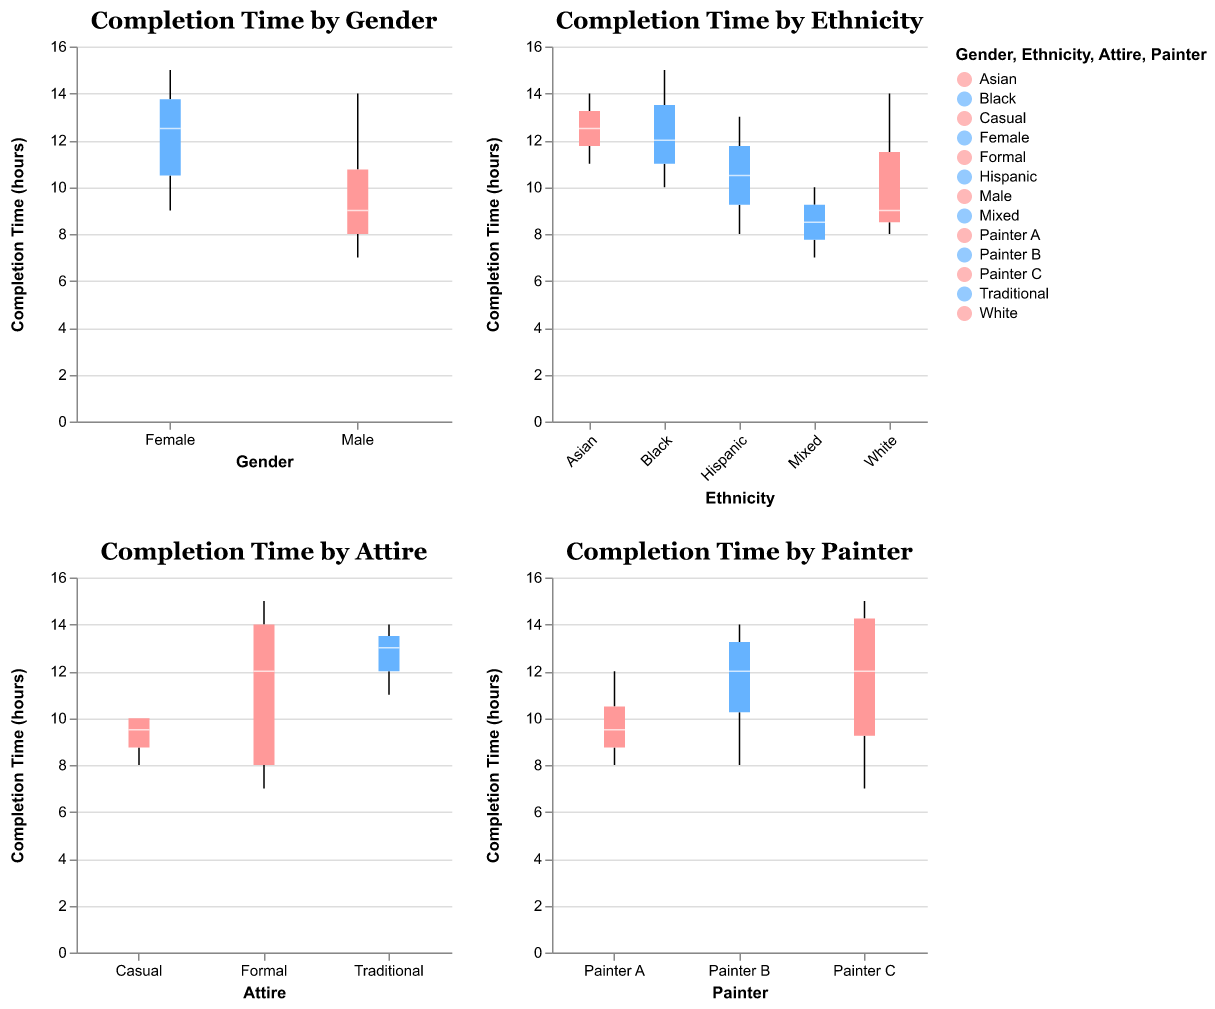How many gender categories are represented in the plot? There are box plots for two gender categories: Male and Female, as indicated by the x-axis labels in the "Completion Time by Gender" subplot.
Answer: 2 Which ethnicity has the widest range of completion times? In the "Completion Time by Ethnicity" subplot, compare the whisker lengths (representing the range of completion times) for each ethnicity. The box plot for Black has the widest range from the minimum to maximum completion times.
Answer: Black What is the average completion time for subjects wearing formal attire? In the "Completion Time by Attire" subplot, identify the data points for formal attire from the box plot. The completion times are 8, 12, 14, 15. Calculate the average: (8+12+14+15)/4 = 12.25 hours.
Answer: 12.25 hours Which painter has the smallest median completion time? In the "Completion Time by Painter" subplot, compare the median lines within the box plots for each painter. Painter C has the lowest median completion time.
Answer: Painter C Do male or female subjects generally have a higher median completion time? In the "Completion Time by Gender" subplot, compare the positions of the median lines in the box plots for Male and Female. The median line for Female is at a higher completion time than for Male.
Answer: Female Which attire category has the highest variability in completion times? In the "Completion Time by Attire" subplot, assess the spread of the data (whisker length and box size) for each attire. Casual attire shows higher variability than Formal and Traditional.
Answer: Casual What is the range of completion times for subjects painted by Painter A? In the "Completion Time by Painter" subplot, find the minimum and maximum whisker values for Painter A. The range is from 8 to 12 hours. Calculate the range as 12 - 8 = 4 hours.
Answer: 4 hours Between Asian and Hispanic ethnicities, which has a greater median completion time? In the "Completion Time by Ethnicity" subplot, compare the median lines within the box plots for Asian and Hispanic subjects. The median line for Asian is higher than for Hispanic.
Answer: Asian 